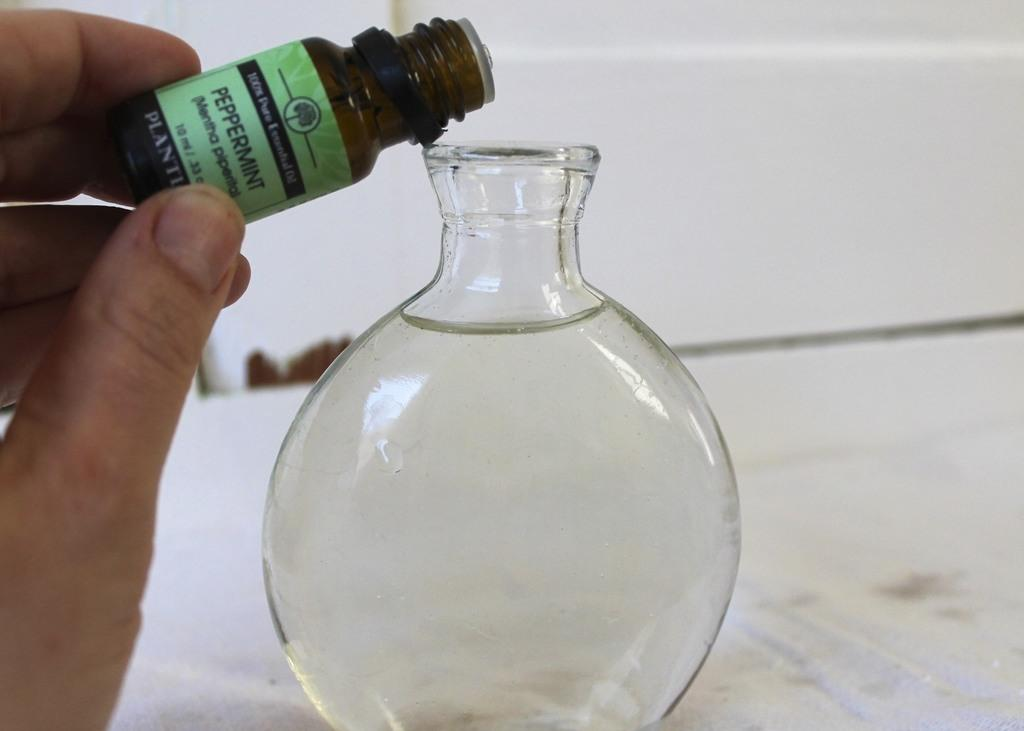What can be seen in the person's hand in the image? There is a chemical bottle in the person's hand. What other object is present in the image? There is a round bottom flask in the image. What is inside the round bottom flask? The round bottom flask contains water. What type of joke is being told by the duck in the image? There is no duck present in the image, so it is not possible to determine if a joke is being told. 